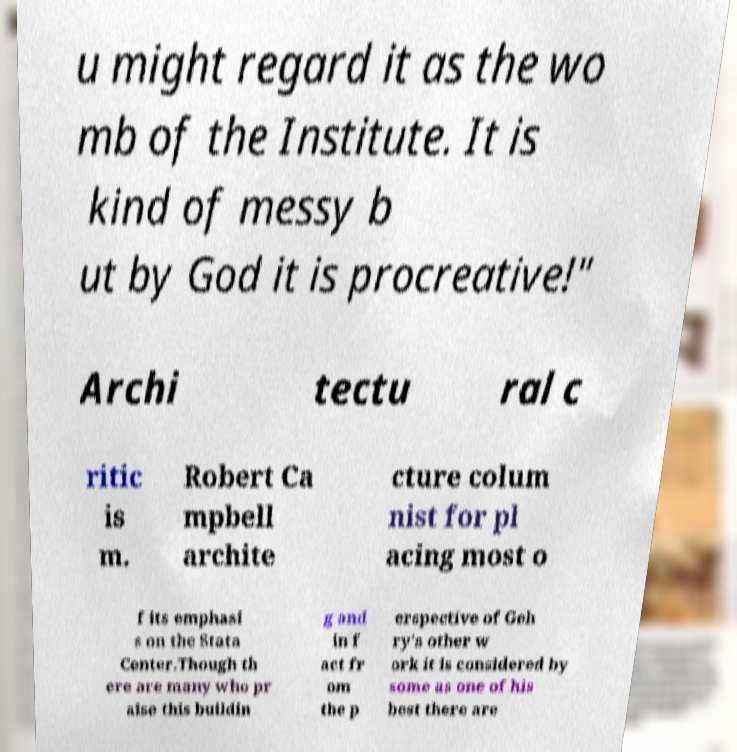Can you accurately transcribe the text from the provided image for me? u might regard it as the wo mb of the Institute. It is kind of messy b ut by God it is procreative!" Archi tectu ral c ritic is m. Robert Ca mpbell archite cture colum nist for pl acing most o f its emphasi s on the Stata Center.Though th ere are many who pr aise this buildin g and in f act fr om the p erspective of Geh ry's other w ork it is considered by some as one of his best there are 